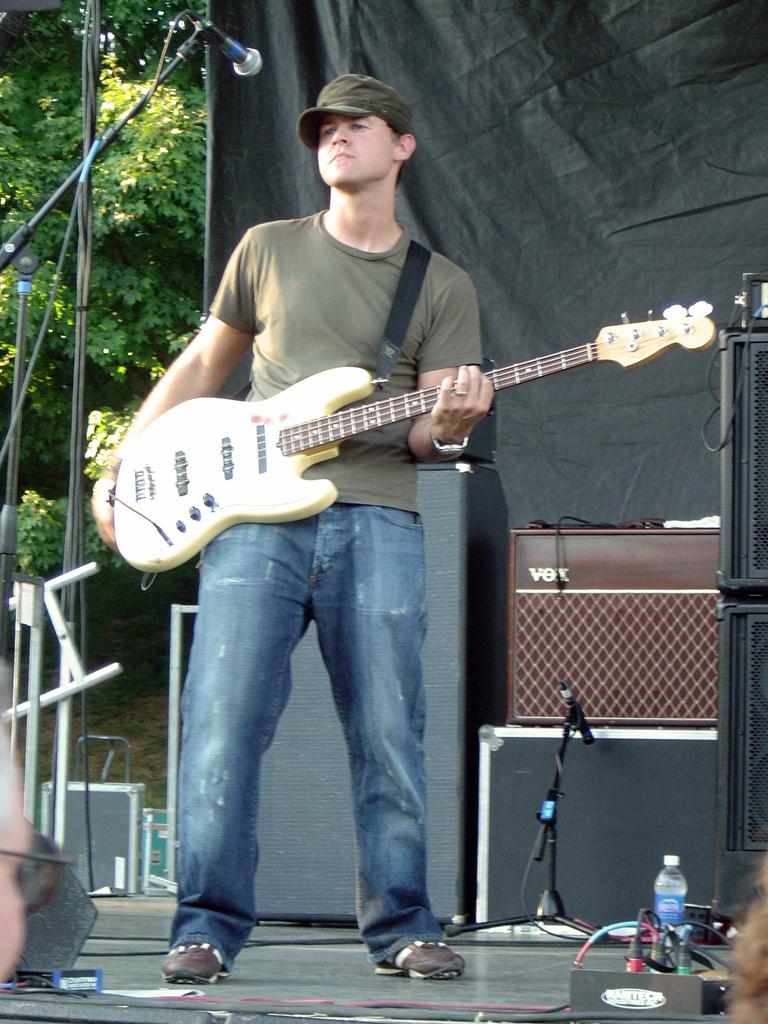Please provide a concise description of this image. In this picture, man in grey t-shirt is holding guitar in his hands and in front of him, we see a microphone. Man is even wearing cap. Beside him, we see many speaker box and behind that, we see a sheet which is black in color. On left corner of picture, we see many trees. 